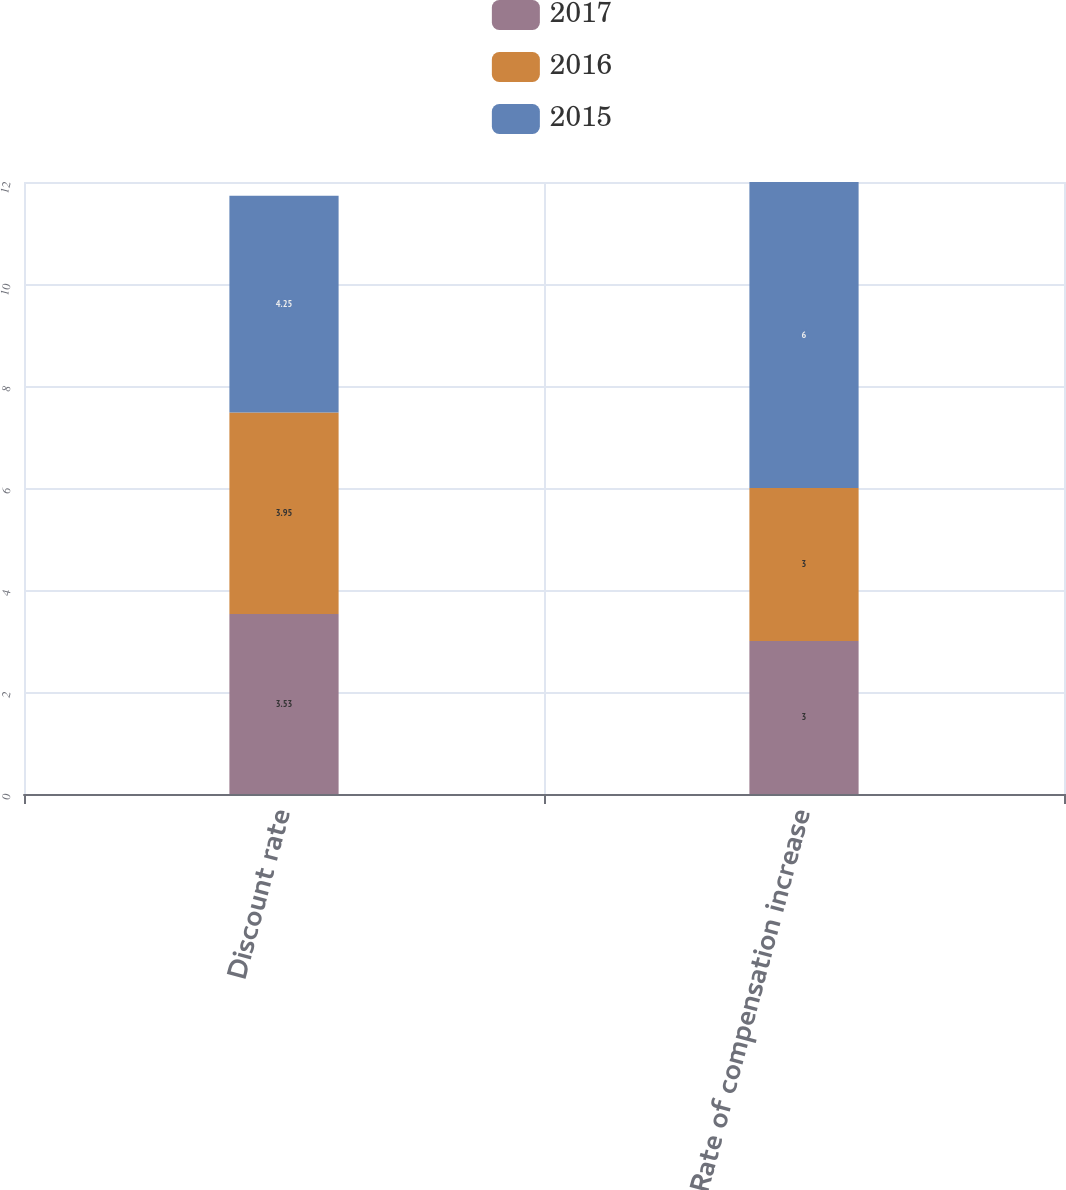Convert chart. <chart><loc_0><loc_0><loc_500><loc_500><stacked_bar_chart><ecel><fcel>Discount rate<fcel>Rate of compensation increase<nl><fcel>2017<fcel>3.53<fcel>3<nl><fcel>2016<fcel>3.95<fcel>3<nl><fcel>2015<fcel>4.25<fcel>6<nl></chart> 